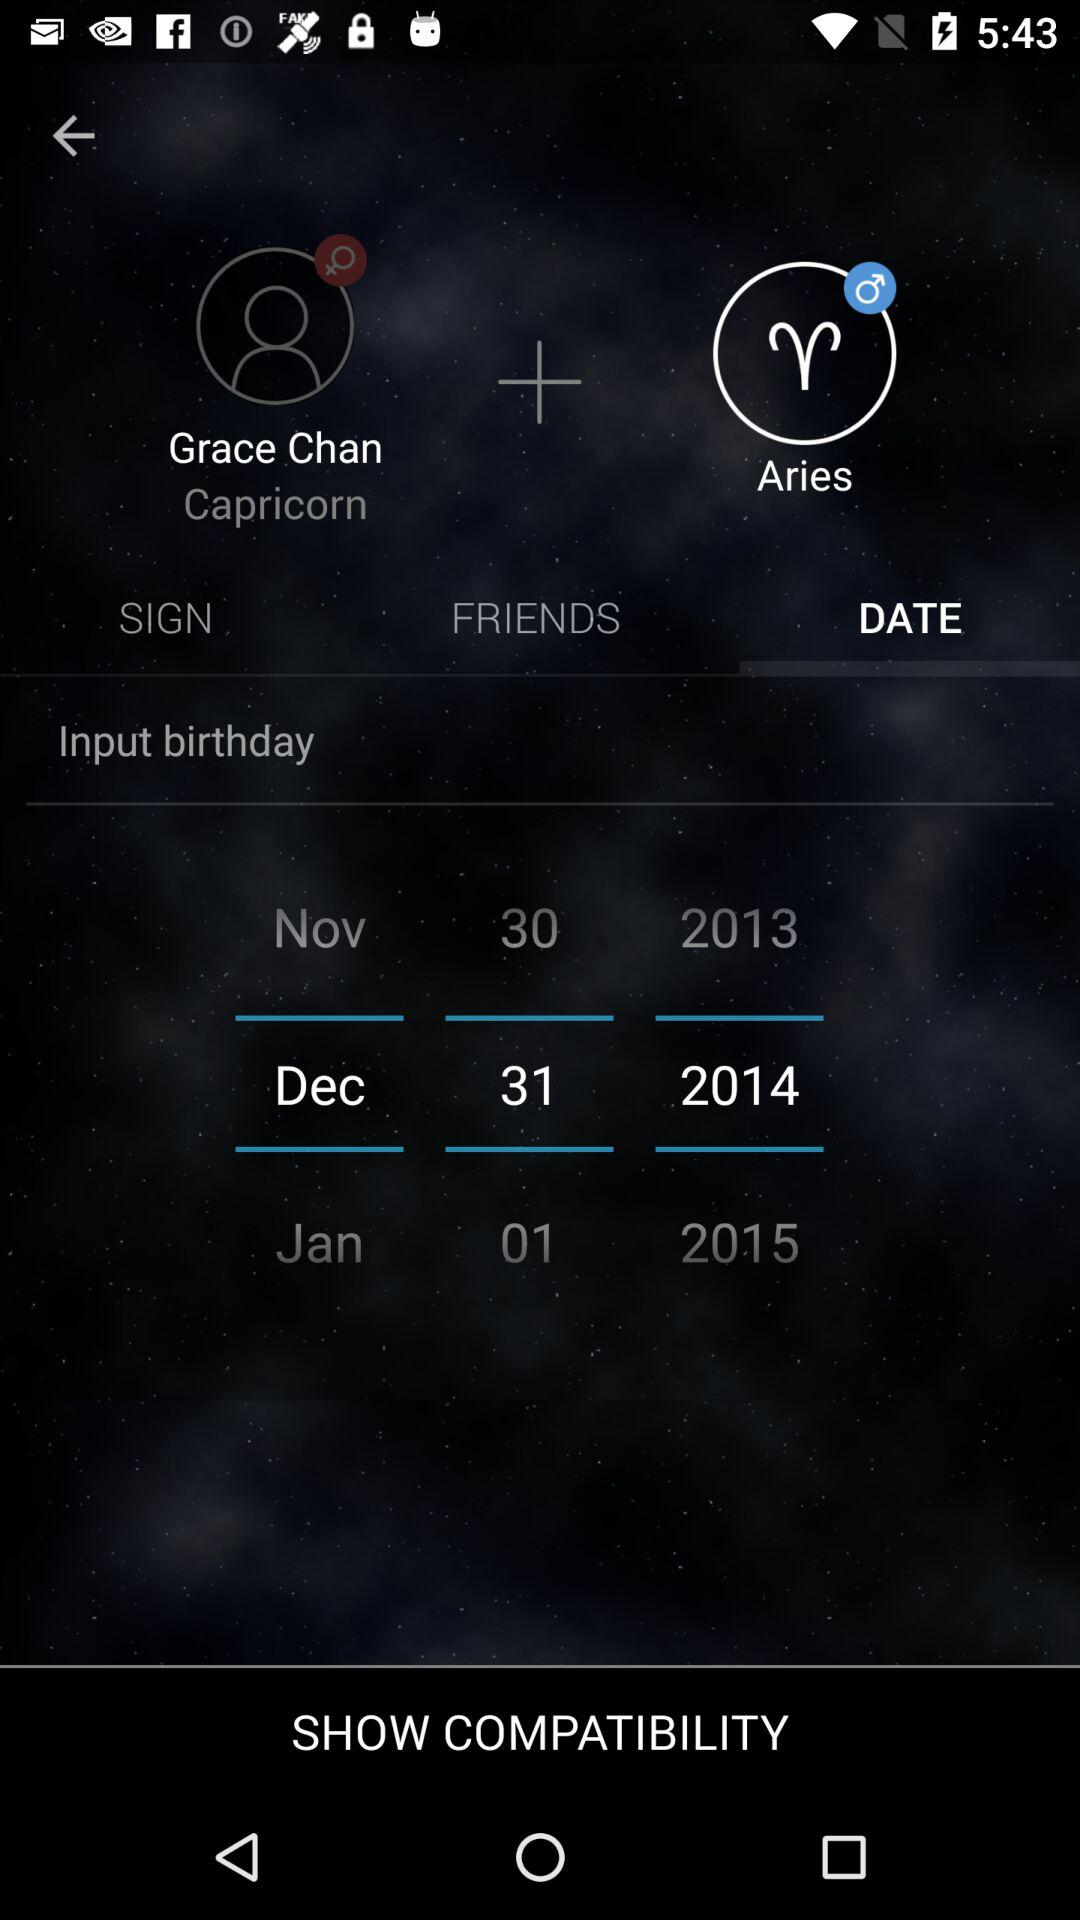What horoscope is added to Grace Chan? The horoscope which is added to Grace Chan is "Capricorn". 